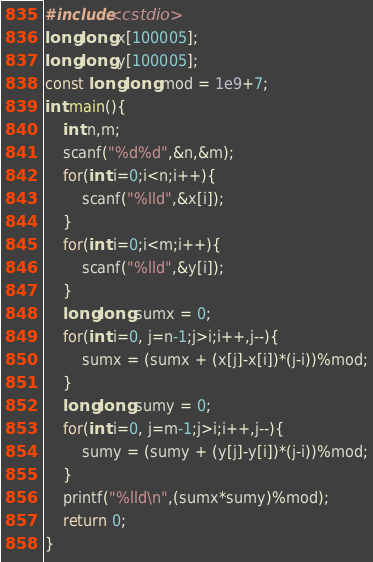Convert code to text. <code><loc_0><loc_0><loc_500><loc_500><_C++_>#include<cstdio>
long long x[100005];
long long y[100005];
const long long mod = 1e9+7;
int main(){
    int n,m;
    scanf("%d%d",&n,&m);
    for(int i=0;i<n;i++){
        scanf("%lld",&x[i]);
    }
    for(int i=0;i<m;i++){
        scanf("%lld",&y[i]);
    }
    long long sumx = 0;
    for(int i=0, j=n-1;j>i;i++,j--){
        sumx = (sumx + (x[j]-x[i])*(j-i))%mod;
    }
    long long sumy = 0;
    for(int i=0, j=m-1;j>i;i++,j--){
        sumy = (sumy + (y[j]-y[i])*(j-i))%mod;
    }
    printf("%lld\n",(sumx*sumy)%mod);
    return 0;
}
</code> 